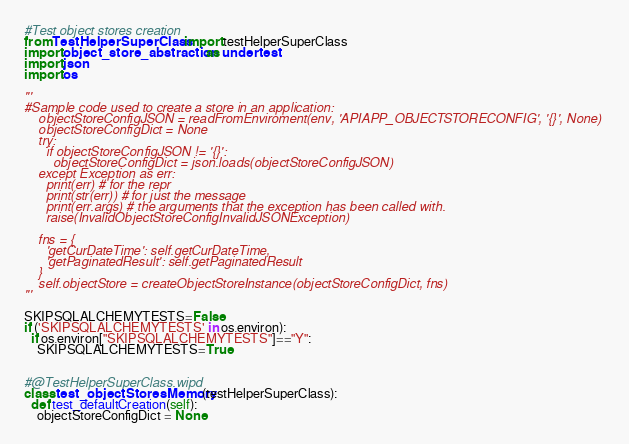<code> <loc_0><loc_0><loc_500><loc_500><_Python_>#Test object stores creation
from TestHelperSuperClass import testHelperSuperClass
import object_store_abstraction as undertest
import json
import os

'''
#Sample code used to create a store in an application:
    objectStoreConfigJSON = readFromEnviroment(env, 'APIAPP_OBJECTSTORECONFIG', '{}', None)
    objectStoreConfigDict = None
    try:
      if objectStoreConfigJSON != '{}':
        objectStoreConfigDict = json.loads(objectStoreConfigJSON)
    except Exception as err:
      print(err) # for the repr
      print(str(err)) # for just the message
      print(err.args) # the arguments that the exception has been called with.
      raise(InvalidObjectStoreConfigInvalidJSONException)

    fns = {
      'getCurDateTime': self.getCurDateTime,
      'getPaginatedResult': self.getPaginatedResult
    }
    self.objectStore = createObjectStoreInstance(objectStoreConfigDict, fns)
'''

SKIPSQLALCHEMYTESTS=False
if ('SKIPSQLALCHEMYTESTS' in os.environ):
  if os.environ["SKIPSQLALCHEMYTESTS"]=="Y":
    SKIPSQLALCHEMYTESTS=True


#@TestHelperSuperClass.wipd
class test_objectStoresMemory(testHelperSuperClass):
  def test_defaultCreation(self):
    objectStoreConfigDict = None</code> 